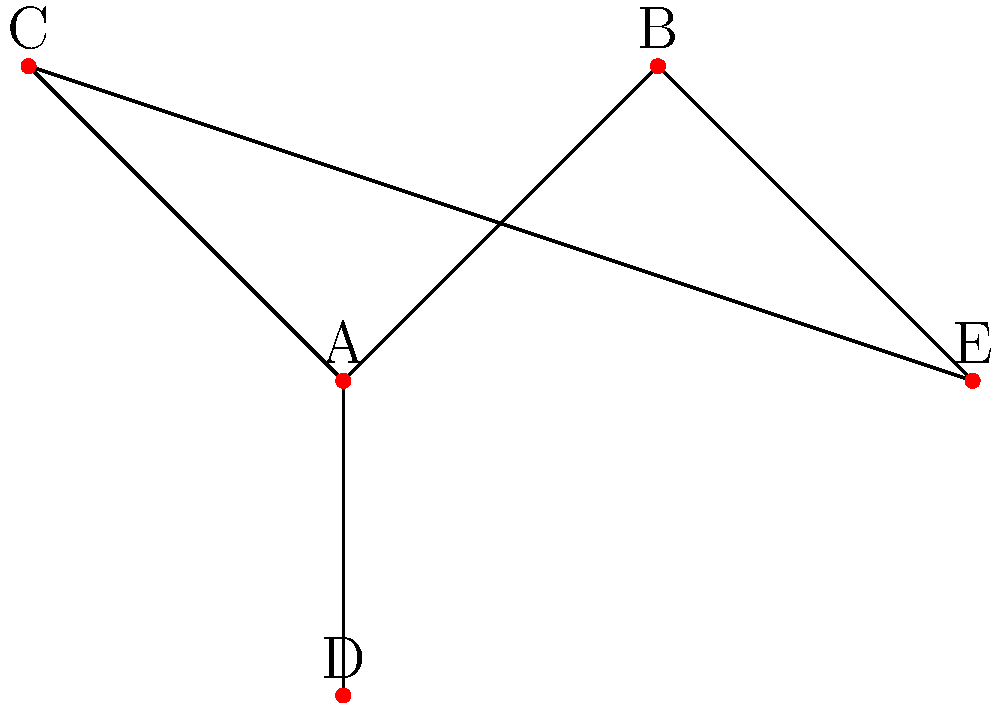In a novel, you've created a complex web of character relationships. Using the network diagram above to represent these relationships, which character serves as the central connection point, potentially acting as a pivotal figure in the story's plot development? To determine the central character in this network diagram, we need to analyze the connections between the characters:

1. First, count the number of connections for each character:
   - Character A: 3 connections (to B, C, and D)
   - Character B: 2 connections (to A and E)
   - Character C: 2 connections (to A and E)
   - Character D: 1 connection (to A)
   - Character E: 2 connections (to B and C)

2. Observe that character A has the most connections (3) compared to the others.

3. Notice that A is directly connected to three out of the four other characters (B, C, and D).

4. A's position in the diagram is central, with other characters branching out from it.

5. Even though A is not directly connected to E, it's indirectly connected through both B and C, showing its influence extends to all characters.

Given these observations, character A serves as the central connection point in this network of relationships. In storytelling terms, this character would likely play a pivotal role in the plot, potentially influencing or connecting the storylines of all other characters.
Answer: Character A 